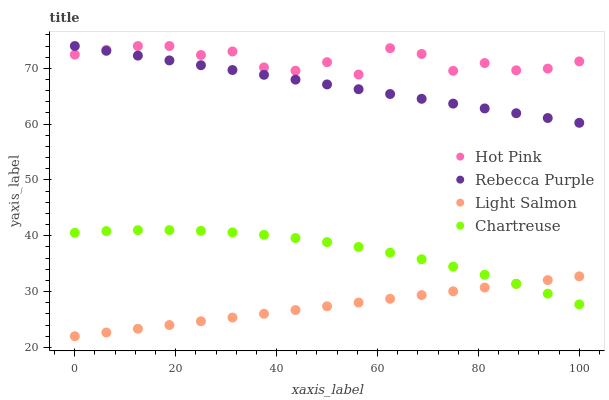Does Light Salmon have the minimum area under the curve?
Answer yes or no. Yes. Does Hot Pink have the maximum area under the curve?
Answer yes or no. Yes. Does Rebecca Purple have the minimum area under the curve?
Answer yes or no. No. Does Rebecca Purple have the maximum area under the curve?
Answer yes or no. No. Is Light Salmon the smoothest?
Answer yes or no. Yes. Is Hot Pink the roughest?
Answer yes or no. Yes. Is Rebecca Purple the smoothest?
Answer yes or no. No. Is Rebecca Purple the roughest?
Answer yes or no. No. Does Light Salmon have the lowest value?
Answer yes or no. Yes. Does Rebecca Purple have the lowest value?
Answer yes or no. No. Does Rebecca Purple have the highest value?
Answer yes or no. Yes. Does Chartreuse have the highest value?
Answer yes or no. No. Is Light Salmon less than Hot Pink?
Answer yes or no. Yes. Is Hot Pink greater than Chartreuse?
Answer yes or no. Yes. Does Chartreuse intersect Light Salmon?
Answer yes or no. Yes. Is Chartreuse less than Light Salmon?
Answer yes or no. No. Is Chartreuse greater than Light Salmon?
Answer yes or no. No. Does Light Salmon intersect Hot Pink?
Answer yes or no. No. 